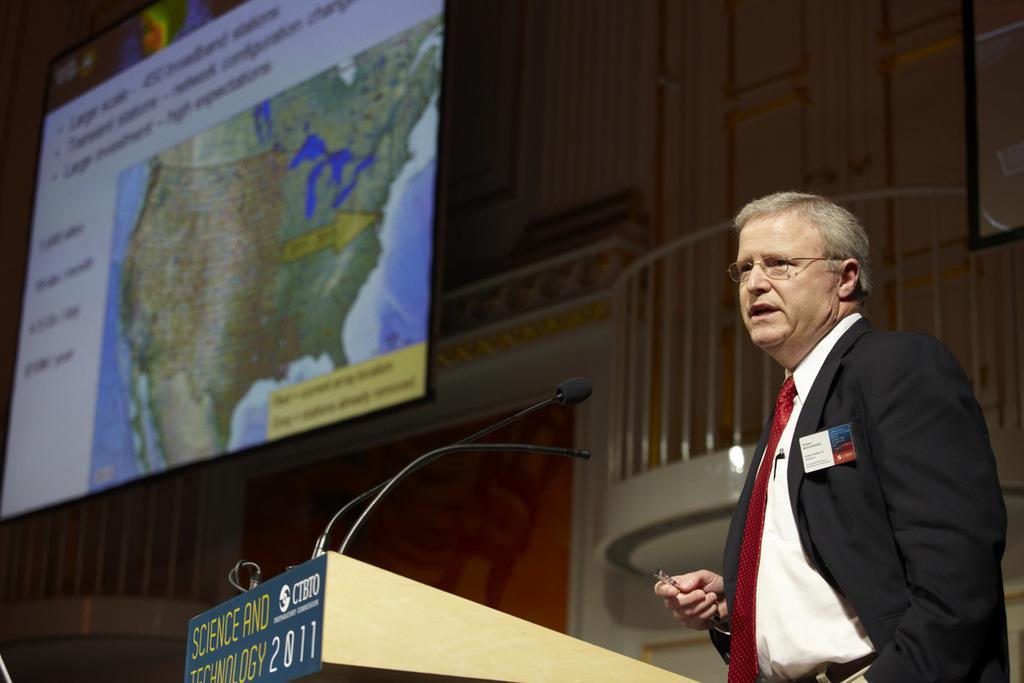Could you give a brief overview of what you see in this image? In this image we can see persons standing at the desk. On the desk we can see mics. In the background we can see wall, screen. 